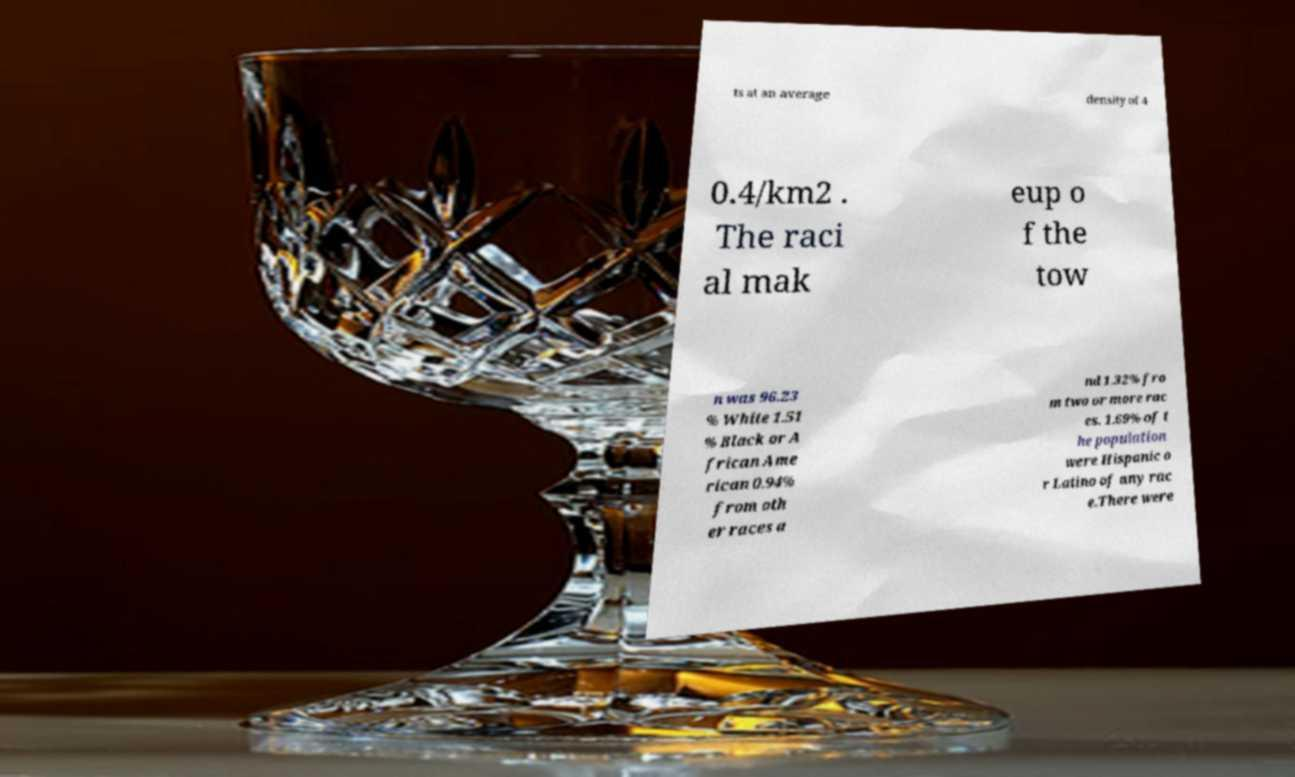Please identify and transcribe the text found in this image. ts at an average density of 4 0.4/km2 . The raci al mak eup o f the tow n was 96.23 % White 1.51 % Black or A frican Ame rican 0.94% from oth er races a nd 1.32% fro m two or more rac es. 1.69% of t he population were Hispanic o r Latino of any rac e.There were 